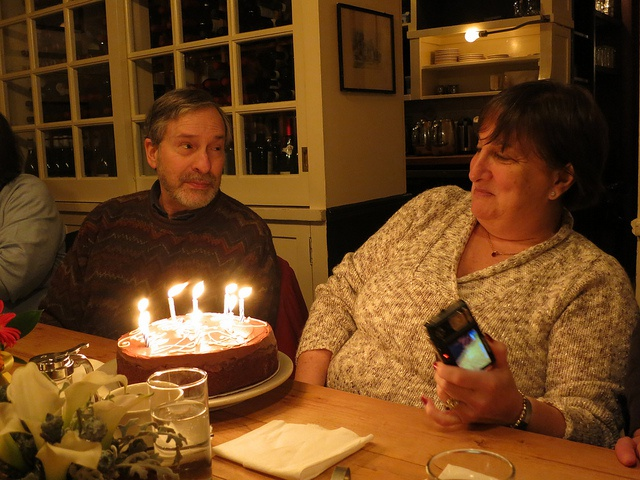Describe the objects in this image and their specific colors. I can see people in black, brown, maroon, and orange tones, dining table in black, brown, maroon, and orange tones, people in black, maroon, and brown tones, cake in black, maroon, ivory, and tan tones, and people in black, olive, and gray tones in this image. 